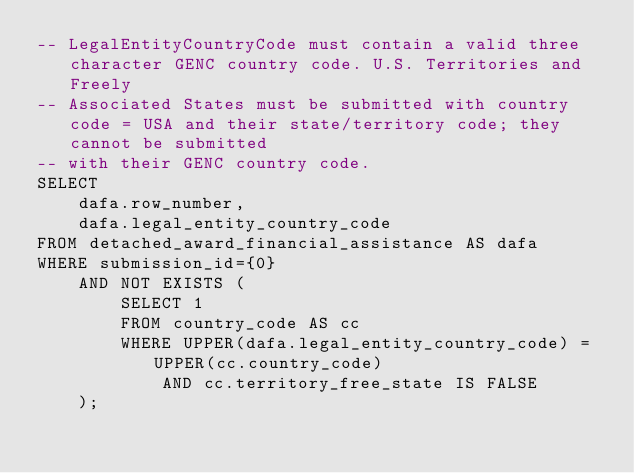Convert code to text. <code><loc_0><loc_0><loc_500><loc_500><_SQL_>-- LegalEntityCountryCode must contain a valid three character GENC country code. U.S. Territories and Freely
-- Associated States must be submitted with country code = USA and their state/territory code; they cannot be submitted
-- with their GENC country code.
SELECT
    dafa.row_number,
    dafa.legal_entity_country_code
FROM detached_award_financial_assistance AS dafa
WHERE submission_id={0}
    AND NOT EXISTS (
        SELECT 1
        FROM country_code AS cc
        WHERE UPPER(dafa.legal_entity_country_code) = UPPER(cc.country_code)
            AND cc.territory_free_state IS FALSE
    );
</code> 